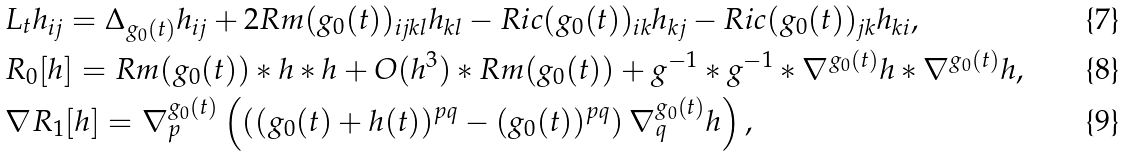<formula> <loc_0><loc_0><loc_500><loc_500>& L _ { t } h _ { i j } = \Delta _ { g _ { 0 } ( t ) } h _ { i j } + 2 R m ( g _ { 0 } ( t ) ) _ { i j k l } h _ { k l } - R i c ( g _ { 0 } ( t ) ) _ { i k } h _ { k j } - R i c ( g _ { 0 } ( t ) ) _ { j k } h _ { k i } , \\ & R _ { 0 } [ h ] = R m ( g _ { 0 } ( t ) ) * h * h + O ( h ^ { 3 } ) * R m ( g _ { 0 } ( t ) ) + g ^ { - 1 } * g ^ { - 1 } * \nabla ^ { g _ { 0 } ( t ) } h * \nabla ^ { g _ { 0 } ( t ) } h , \\ & \nabla R _ { 1 } [ h ] = \nabla _ { p } ^ { g _ { 0 } ( t ) } \left ( \left ( ( g _ { 0 } ( t ) + h ( t ) ) ^ { p q } - ( g _ { 0 } ( t ) ) ^ { p q } \right ) \nabla _ { q } ^ { g _ { 0 } ( t ) } h \right ) ,</formula> 